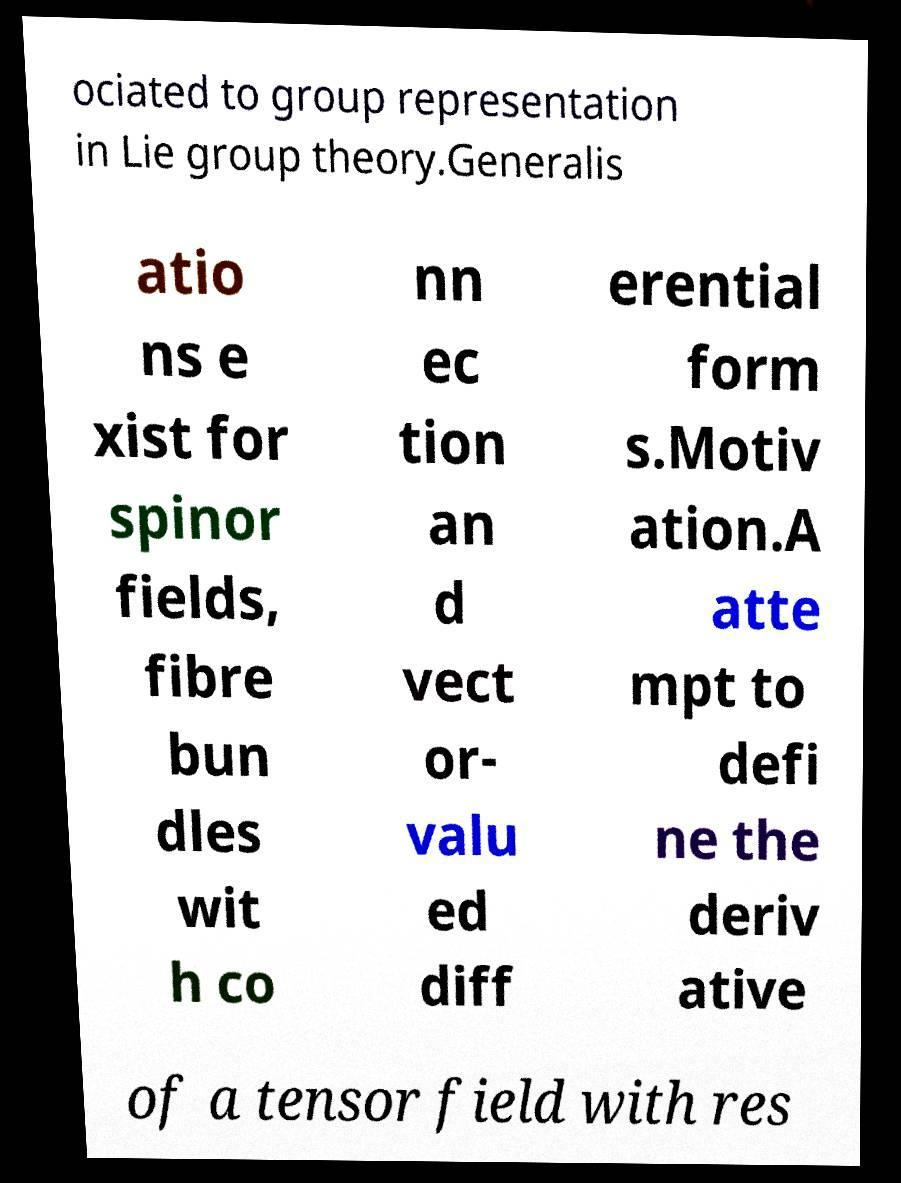There's text embedded in this image that I need extracted. Can you transcribe it verbatim? ociated to group representation in Lie group theory.Generalis atio ns e xist for spinor fields, fibre bun dles wit h co nn ec tion an d vect or- valu ed diff erential form s.Motiv ation.A atte mpt to defi ne the deriv ative of a tensor field with res 